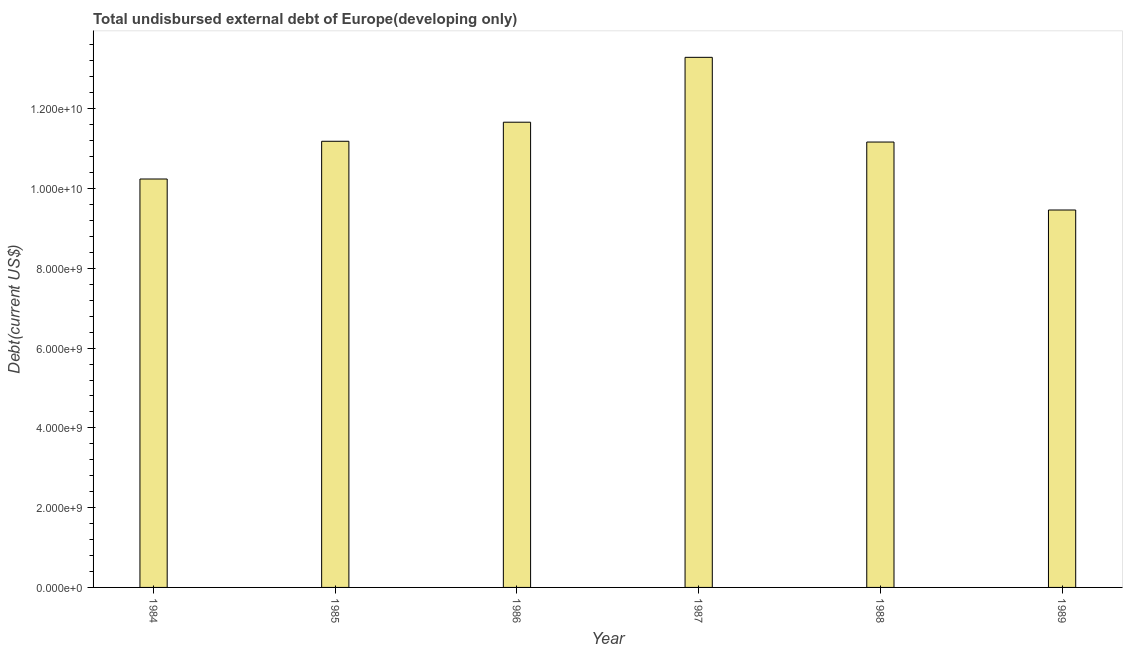Does the graph contain grids?
Provide a short and direct response. No. What is the title of the graph?
Make the answer very short. Total undisbursed external debt of Europe(developing only). What is the label or title of the X-axis?
Your answer should be very brief. Year. What is the label or title of the Y-axis?
Make the answer very short. Debt(current US$). What is the total debt in 1987?
Your response must be concise. 1.33e+1. Across all years, what is the maximum total debt?
Ensure brevity in your answer.  1.33e+1. Across all years, what is the minimum total debt?
Keep it short and to the point. 9.46e+09. What is the sum of the total debt?
Offer a terse response. 6.70e+1. What is the difference between the total debt in 1987 and 1988?
Keep it short and to the point. 2.12e+09. What is the average total debt per year?
Offer a very short reply. 1.12e+1. What is the median total debt?
Offer a very short reply. 1.12e+1. What is the ratio of the total debt in 1985 to that in 1987?
Make the answer very short. 0.84. Is the difference between the total debt in 1985 and 1987 greater than the difference between any two years?
Offer a very short reply. No. What is the difference between the highest and the second highest total debt?
Your answer should be compact. 1.63e+09. What is the difference between the highest and the lowest total debt?
Offer a very short reply. 3.83e+09. How many bars are there?
Offer a very short reply. 6. Are all the bars in the graph horizontal?
Your answer should be compact. No. What is the Debt(current US$) of 1984?
Provide a short and direct response. 1.02e+1. What is the Debt(current US$) in 1985?
Make the answer very short. 1.12e+1. What is the Debt(current US$) of 1986?
Offer a very short reply. 1.17e+1. What is the Debt(current US$) of 1987?
Your response must be concise. 1.33e+1. What is the Debt(current US$) of 1988?
Make the answer very short. 1.12e+1. What is the Debt(current US$) in 1989?
Your answer should be very brief. 9.46e+09. What is the difference between the Debt(current US$) in 1984 and 1985?
Offer a terse response. -9.46e+08. What is the difference between the Debt(current US$) in 1984 and 1986?
Make the answer very short. -1.42e+09. What is the difference between the Debt(current US$) in 1984 and 1987?
Your answer should be compact. -3.05e+09. What is the difference between the Debt(current US$) in 1984 and 1988?
Your answer should be very brief. -9.27e+08. What is the difference between the Debt(current US$) in 1984 and 1989?
Ensure brevity in your answer.  7.77e+08. What is the difference between the Debt(current US$) in 1985 and 1986?
Ensure brevity in your answer.  -4.78e+08. What is the difference between the Debt(current US$) in 1985 and 1987?
Offer a very short reply. -2.10e+09. What is the difference between the Debt(current US$) in 1985 and 1988?
Provide a short and direct response. 1.93e+07. What is the difference between the Debt(current US$) in 1985 and 1989?
Keep it short and to the point. 1.72e+09. What is the difference between the Debt(current US$) in 1986 and 1987?
Your answer should be compact. -1.63e+09. What is the difference between the Debt(current US$) in 1986 and 1988?
Provide a succinct answer. 4.97e+08. What is the difference between the Debt(current US$) in 1986 and 1989?
Your answer should be compact. 2.20e+09. What is the difference between the Debt(current US$) in 1987 and 1988?
Keep it short and to the point. 2.12e+09. What is the difference between the Debt(current US$) in 1987 and 1989?
Your answer should be very brief. 3.83e+09. What is the difference between the Debt(current US$) in 1988 and 1989?
Ensure brevity in your answer.  1.70e+09. What is the ratio of the Debt(current US$) in 1984 to that in 1985?
Ensure brevity in your answer.  0.92. What is the ratio of the Debt(current US$) in 1984 to that in 1986?
Offer a terse response. 0.88. What is the ratio of the Debt(current US$) in 1984 to that in 1987?
Provide a short and direct response. 0.77. What is the ratio of the Debt(current US$) in 1984 to that in 1988?
Ensure brevity in your answer.  0.92. What is the ratio of the Debt(current US$) in 1984 to that in 1989?
Offer a terse response. 1.08. What is the ratio of the Debt(current US$) in 1985 to that in 1986?
Keep it short and to the point. 0.96. What is the ratio of the Debt(current US$) in 1985 to that in 1987?
Provide a succinct answer. 0.84. What is the ratio of the Debt(current US$) in 1985 to that in 1989?
Offer a terse response. 1.18. What is the ratio of the Debt(current US$) in 1986 to that in 1987?
Keep it short and to the point. 0.88. What is the ratio of the Debt(current US$) in 1986 to that in 1988?
Provide a succinct answer. 1.04. What is the ratio of the Debt(current US$) in 1986 to that in 1989?
Ensure brevity in your answer.  1.23. What is the ratio of the Debt(current US$) in 1987 to that in 1988?
Ensure brevity in your answer.  1.19. What is the ratio of the Debt(current US$) in 1987 to that in 1989?
Your answer should be compact. 1.41. What is the ratio of the Debt(current US$) in 1988 to that in 1989?
Offer a very short reply. 1.18. 